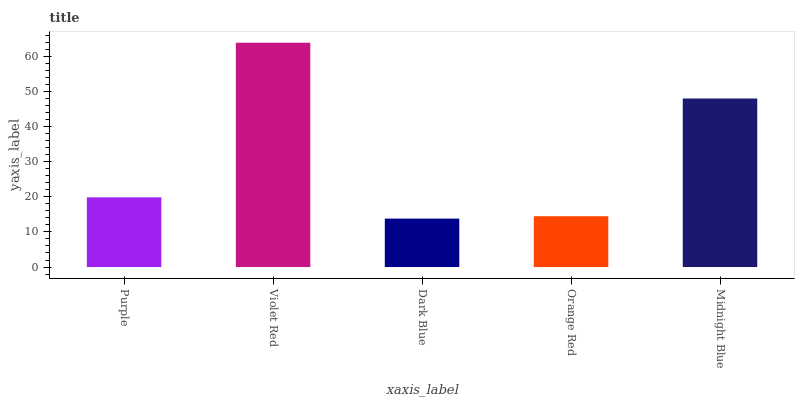Is Dark Blue the minimum?
Answer yes or no. Yes. Is Violet Red the maximum?
Answer yes or no. Yes. Is Violet Red the minimum?
Answer yes or no. No. Is Dark Blue the maximum?
Answer yes or no. No. Is Violet Red greater than Dark Blue?
Answer yes or no. Yes. Is Dark Blue less than Violet Red?
Answer yes or no. Yes. Is Dark Blue greater than Violet Red?
Answer yes or no. No. Is Violet Red less than Dark Blue?
Answer yes or no. No. Is Purple the high median?
Answer yes or no. Yes. Is Purple the low median?
Answer yes or no. Yes. Is Violet Red the high median?
Answer yes or no. No. Is Orange Red the low median?
Answer yes or no. No. 